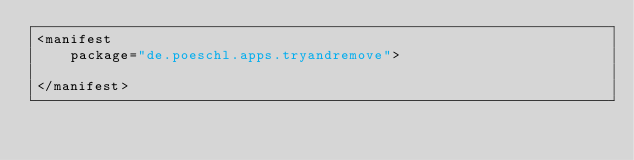<code> <loc_0><loc_0><loc_500><loc_500><_XML_><manifest
    package="de.poeschl.apps.tryandremove">

</manifest>
</code> 